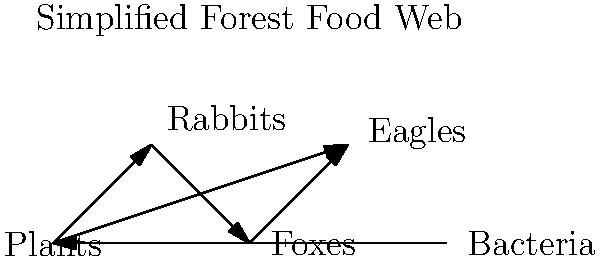In the simplified forest food web shown above, which species would be most directly affected if the rabbit population suddenly decreased due to a disease outbreak? How might this impact your efforts as a wildlife artist to raise awareness for endangered species conservation? To answer this question, we need to analyze the food web diagram and understand the relationships between species:

1. Identify the rabbit's position in the food web:
   - Rabbits are primary consumers, feeding on plants.
   - Rabbits are prey for foxes.

2. Determine direct connections to rabbits:
   - Plants are directly below rabbits in the food chain.
   - Foxes are directly above rabbits in the food chain.

3. Analyze the impact of a rabbit population decrease:
   - Foxes would be most directly affected as they lose a primary food source.
   - Plants might experience a temporary increase due to reduced grazing pressure.

4. Consider secondary effects:
   - Eagles might be indirectly affected if fox populations decline.
   - Bacteria could be impacted by changes in plant and animal biomass.

5. Relate to endangered species conservation:
   - As a wildlife artist, this scenario highlights the interconnectedness of ecosystems.
   - It demonstrates how changes in one species can have cascading effects on others.
   - This knowledge can be used to create artwork that illustrates the delicate balance in ecosystems and the importance of preserving all species, not just the charismatic ones.

6. Conclude:
   Foxes would be most directly affected by a sudden decrease in rabbit population, potentially becoming more vulnerable to endangerment themselves.
Answer: Foxes 